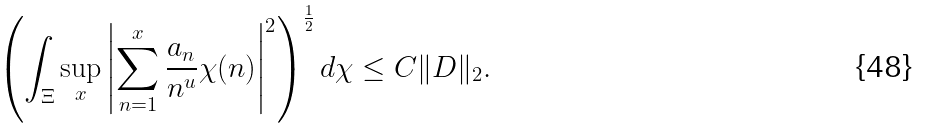<formula> <loc_0><loc_0><loc_500><loc_500>\left ( \int _ { \Xi } \sup _ { x } \left | \sum _ { n = 1 } ^ { x } \frac { a _ { n } } { n ^ { u } } \chi ( n ) \right | ^ { 2 } \right ) ^ { \frac { 1 } { 2 } } d \chi \leq C \| D \| _ { 2 } .</formula> 